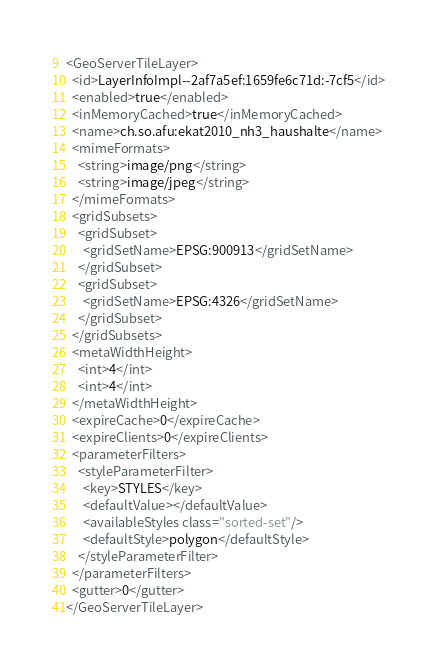<code> <loc_0><loc_0><loc_500><loc_500><_XML_><GeoServerTileLayer>
  <id>LayerInfoImpl--2af7a5ef:1659fe6c71d:-7cf5</id>
  <enabled>true</enabled>
  <inMemoryCached>true</inMemoryCached>
  <name>ch.so.afu:ekat2010_nh3_haushalte</name>
  <mimeFormats>
    <string>image/png</string>
    <string>image/jpeg</string>
  </mimeFormats>
  <gridSubsets>
    <gridSubset>
      <gridSetName>EPSG:900913</gridSetName>
    </gridSubset>
    <gridSubset>
      <gridSetName>EPSG:4326</gridSetName>
    </gridSubset>
  </gridSubsets>
  <metaWidthHeight>
    <int>4</int>
    <int>4</int>
  </metaWidthHeight>
  <expireCache>0</expireCache>
  <expireClients>0</expireClients>
  <parameterFilters>
    <styleParameterFilter>
      <key>STYLES</key>
      <defaultValue></defaultValue>
      <availableStyles class="sorted-set"/>
      <defaultStyle>polygon</defaultStyle>
    </styleParameterFilter>
  </parameterFilters>
  <gutter>0</gutter>
</GeoServerTileLayer></code> 